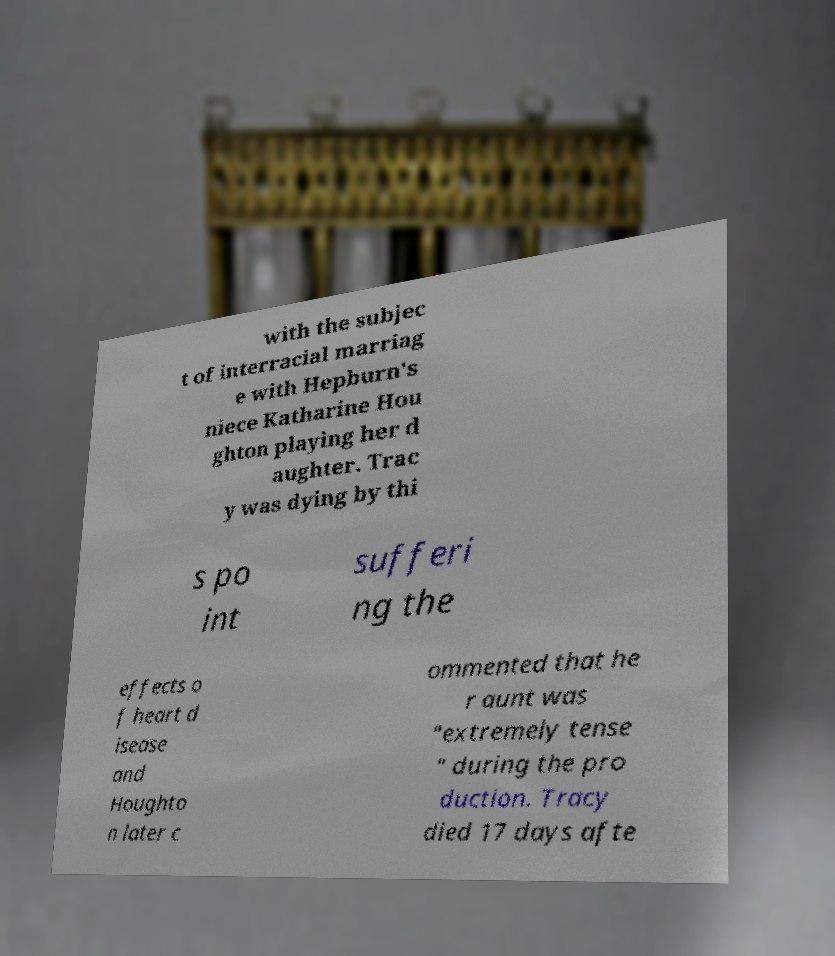Can you read and provide the text displayed in the image?This photo seems to have some interesting text. Can you extract and type it out for me? with the subjec t of interracial marriag e with Hepburn's niece Katharine Hou ghton playing her d aughter. Trac y was dying by thi s po int sufferi ng the effects o f heart d isease and Houghto n later c ommented that he r aunt was "extremely tense " during the pro duction. Tracy died 17 days afte 